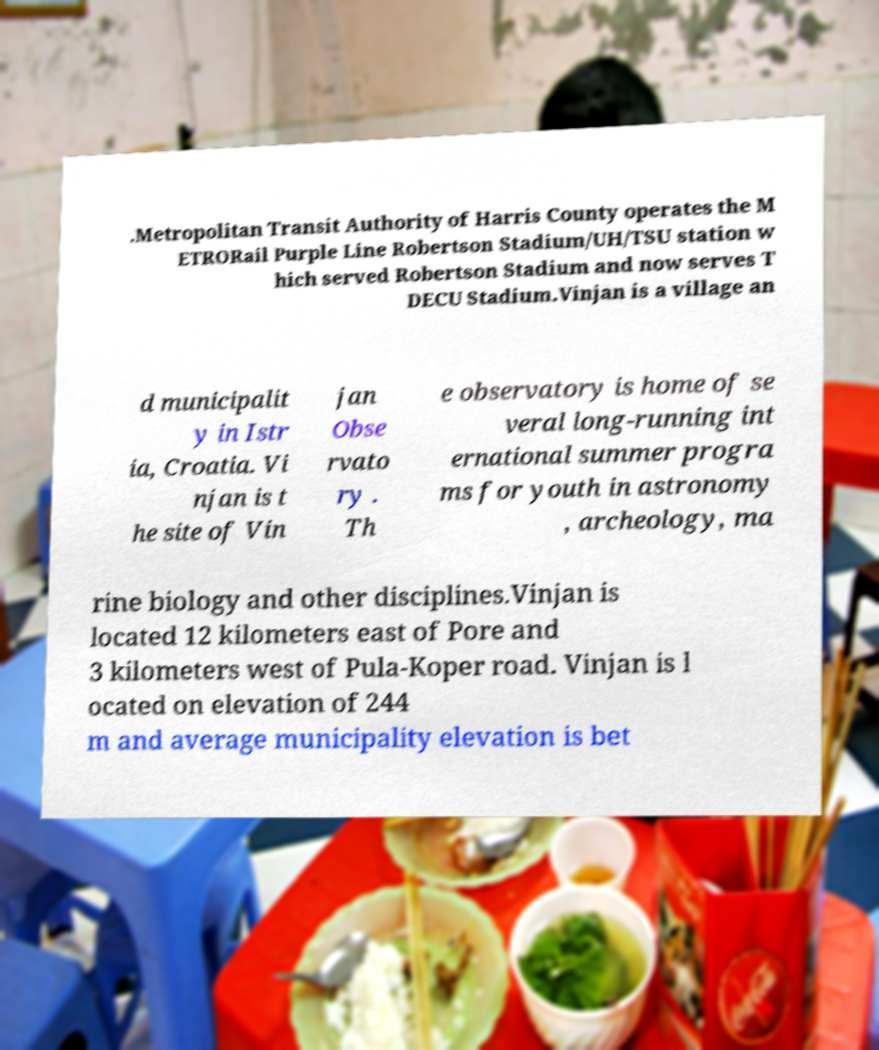Could you assist in decoding the text presented in this image and type it out clearly? .Metropolitan Transit Authority of Harris County operates the M ETRORail Purple Line Robertson Stadium/UH/TSU station w hich served Robertson Stadium and now serves T DECU Stadium.Vinjan is a village an d municipalit y in Istr ia, Croatia. Vi njan is t he site of Vin jan Obse rvato ry . Th e observatory is home of se veral long-running int ernational summer progra ms for youth in astronomy , archeology, ma rine biology and other disciplines.Vinjan is located 12 kilometers east of Pore and 3 kilometers west of Pula-Koper road. Vinjan is l ocated on elevation of 244 m and average municipality elevation is bet 